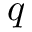<formula> <loc_0><loc_0><loc_500><loc_500>q</formula> 